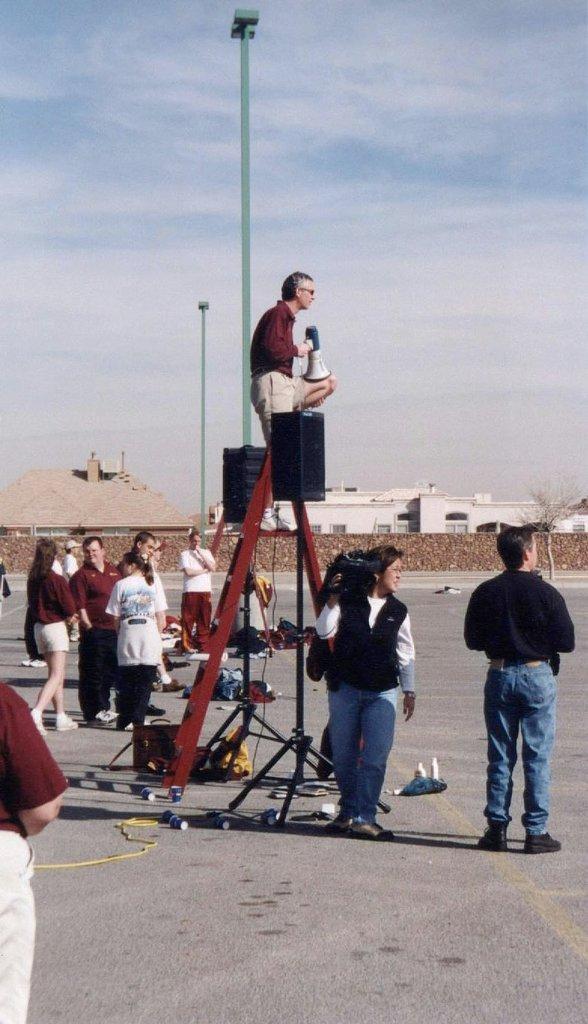How would you summarize this image in a sentence or two? This is the man holding a megaphone and standing on the ladder. These are the speakers with the stands. I can see a woman holding a video recorder and walking. These are the poles. This is the wall. I can see a building. There are group of people standing. I can see few objects placed on the road. This looks like a tree. 